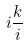<formula> <loc_0><loc_0><loc_500><loc_500>i \frac { k } { i }</formula> 